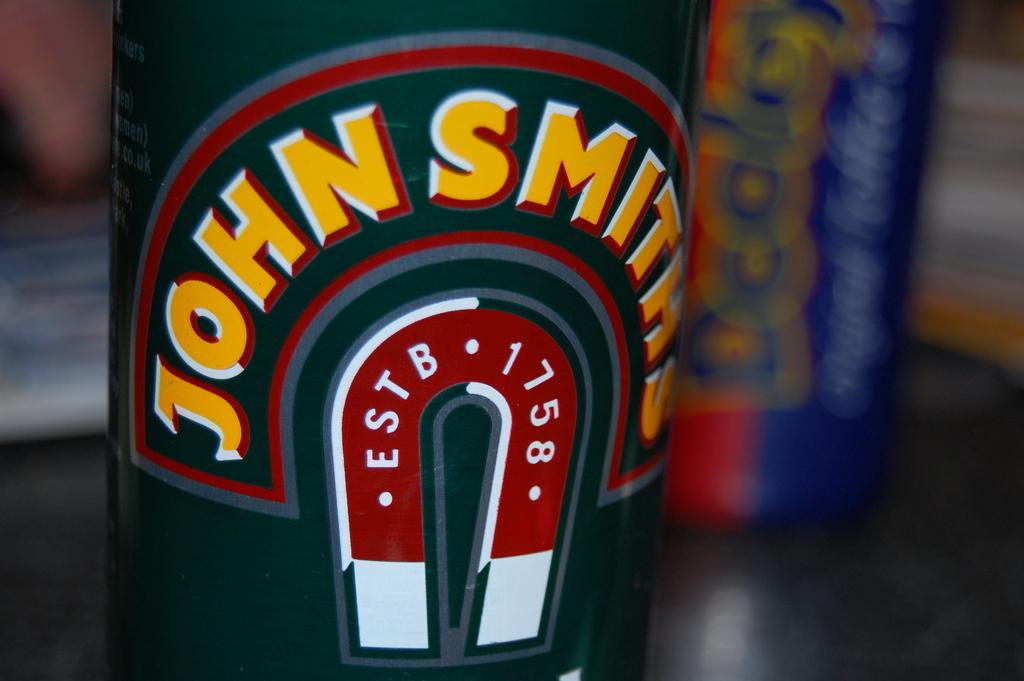<image>
Offer a succinct explanation of the picture presented. A container with the brand name John Smith is sitting on a table and the colors are green,red,white and yellow. 